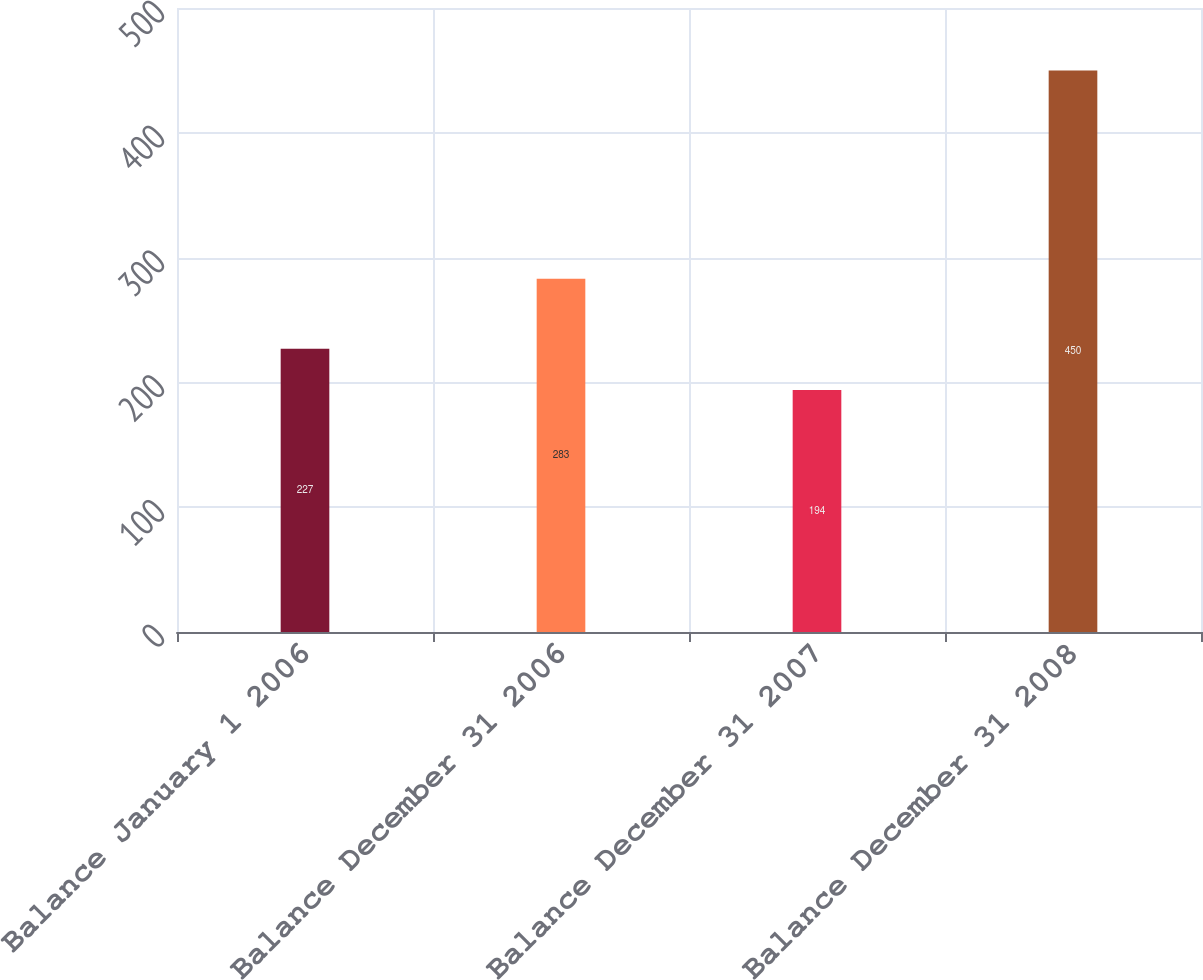Convert chart to OTSL. <chart><loc_0><loc_0><loc_500><loc_500><bar_chart><fcel>Balance January 1 2006<fcel>Balance December 31 2006<fcel>Balance December 31 2007<fcel>Balance December 31 2008<nl><fcel>227<fcel>283<fcel>194<fcel>450<nl></chart> 